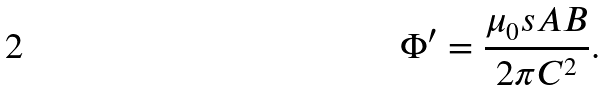<formula> <loc_0><loc_0><loc_500><loc_500>\Phi ^ { \prime } = \frac { \mu _ { 0 } s A B } { 2 { \pi } C ^ { 2 } } .</formula> 